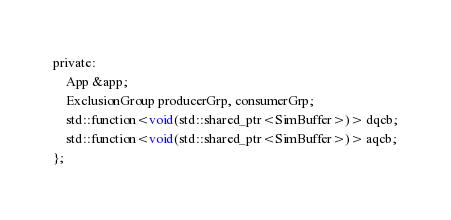Convert code to text. <code><loc_0><loc_0><loc_500><loc_500><_C_>private:
    App &app;
    ExclusionGroup producerGrp, consumerGrp;
    std::function<void(std::shared_ptr<SimBuffer>)> dqcb;
    std::function<void(std::shared_ptr<SimBuffer>)> aqcb;
};
</code> 